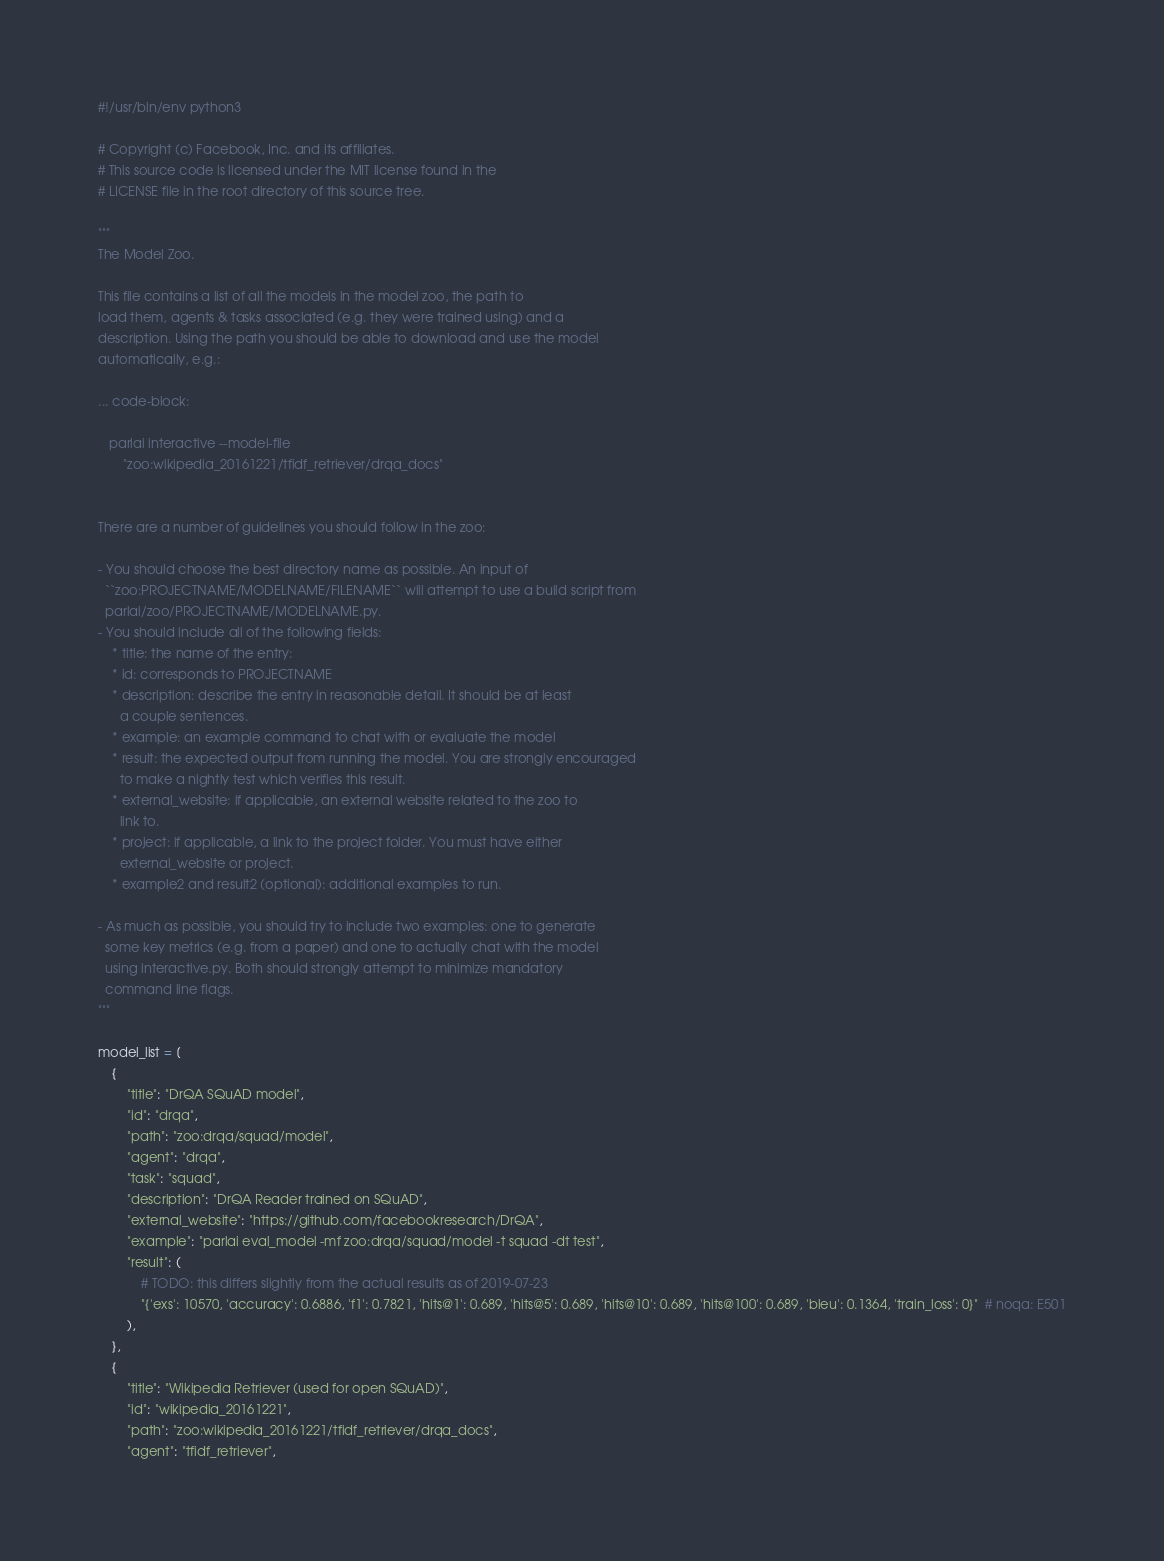<code> <loc_0><loc_0><loc_500><loc_500><_Python_>#!/usr/bin/env python3

# Copyright (c) Facebook, Inc. and its affiliates.
# This source code is licensed under the MIT license found in the
# LICENSE file in the root directory of this source tree.

"""
The Model Zoo.

This file contains a list of all the models in the model zoo, the path to
load them, agents & tasks associated (e.g. they were trained using) and a
description. Using the path you should be able to download and use the model
automatically, e.g.:

... code-block:

   parlai interactive --model-file
       "zoo:wikipedia_20161221/tfidf_retriever/drqa_docs"


There are a number of guidelines you should follow in the zoo:

- You should choose the best directory name as possible. An input of
  ``zoo:PROJECTNAME/MODELNAME/FILENAME`` will attempt to use a build script from
  parlai/zoo/PROJECTNAME/MODELNAME.py.
- You should include all of the following fields:
    * title: the name of the entry:
    * id: corresponds to PROJECTNAME
    * description: describe the entry in reasonable detail. It should be at least
      a couple sentences.
    * example: an example command to chat with or evaluate the model
    * result: the expected output from running the model. You are strongly encouraged
      to make a nightly test which verifies this result.
    * external_website: if applicable, an external website related to the zoo to
      link to.
    * project: if applicable, a link to the project folder. You must have either
      external_website or project.
    * example2 and result2 (optional): additional examples to run.

- As much as possible, you should try to include two examples: one to generate
  some key metrics (e.g. from a paper) and one to actually chat with the model
  using interactive.py. Both should strongly attempt to minimize mandatory
  command line flags.
"""

model_list = [
    {
        "title": "DrQA SQuAD model",
        "id": "drqa",
        "path": "zoo:drqa/squad/model",
        "agent": "drqa",
        "task": "squad",
        "description": "DrQA Reader trained on SQuAD",
        "external_website": "https://github.com/facebookresearch/DrQA",
        "example": "parlai eval_model -mf zoo:drqa/squad/model -t squad -dt test",
        "result": (
            # TODO: this differs slightly from the actual results as of 2019-07-23
            "{'exs': 10570, 'accuracy': 0.6886, 'f1': 0.7821, 'hits@1': 0.689, 'hits@5': 0.689, 'hits@10': 0.689, 'hits@100': 0.689, 'bleu': 0.1364, 'train_loss': 0}"  # noqa: E501
        ),
    },
    {
        "title": "Wikipedia Retriever (used for open SQuAD)",
        "id": "wikipedia_20161221",
        "path": "zoo:wikipedia_20161221/tfidf_retriever/drqa_docs",
        "agent": "tfidf_retriever",</code> 